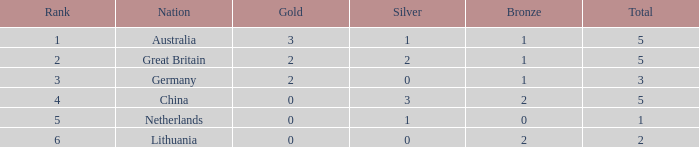What is the total number when silver is 0, bronze is 1, and the standing is less than 3? 0.0. 